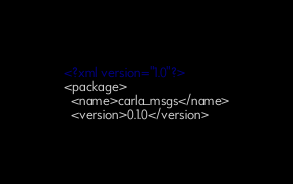Convert code to text. <code><loc_0><loc_0><loc_500><loc_500><_XML_><?xml version="1.0"?>
<package>
  <name>carla_msgs</name>
  <version>0.1.0</version></code> 